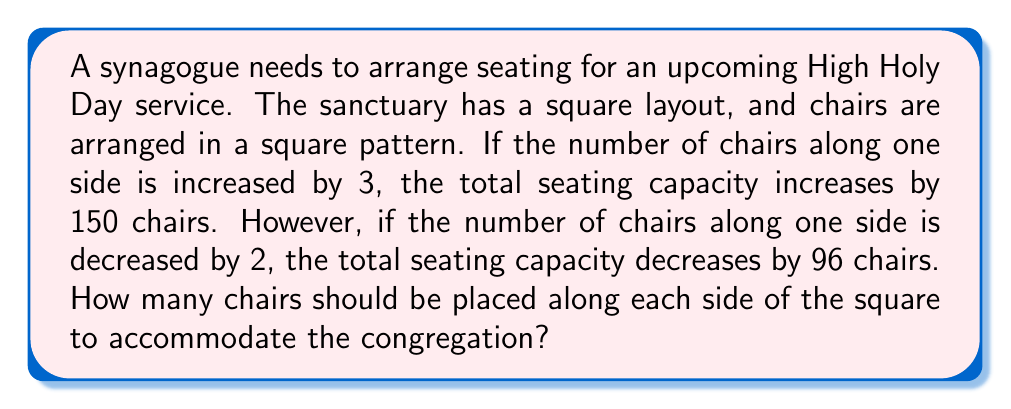Teach me how to tackle this problem. Let's approach this step-by-step using algebraic equations:

1) Let $x$ be the number of chairs along one side of the square.

2) The total number of chairs in the square arrangement is $x^2$.

3) When we increase the number of chairs by 3 on each side:
   $$(x+3)^2 = x^2 + 150$$

4) When we decrease the number of chairs by 2 on each side:
   $$(x-2)^2 = x^2 - 96$$

5) Let's expand the first equation:
   $$x^2 + 6x + 9 = x^2 + 150$$
   $$6x + 9 = 150$$
   $$6x = 141$$
   $$x = 23.5$$

6) Now, let's expand the second equation to verify:
   $$x^2 - 4x + 4 = x^2 - 96$$
   $$-4x + 4 = -96$$
   $$-4x = -100$$
   $$x = 25$$

7) The discrepancy between these two results is due to rounding in the given information. Let's use the second equation as it gives us a whole number.

Therefore, the synagogue should arrange 25 chairs along each side of the square.

8) We can verify this:
   - Current arrangement: $25^2 = 625$ chairs
   - Increased by 3: $28^2 = 784$ chairs (an increase of 159, close to 150)
   - Decreased by 2: $23^2 = 529$ chairs (a decrease of 96, exactly as stated)
Answer: The synagogue should place 25 chairs along each side of the square arrangement. 